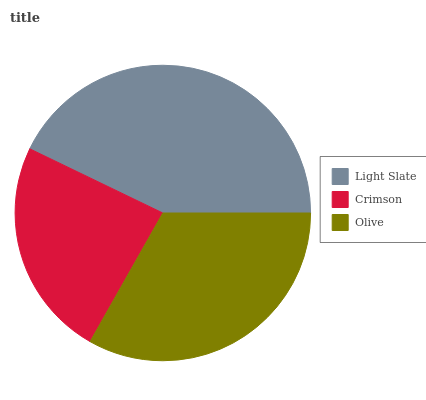Is Crimson the minimum?
Answer yes or no. Yes. Is Light Slate the maximum?
Answer yes or no. Yes. Is Olive the minimum?
Answer yes or no. No. Is Olive the maximum?
Answer yes or no. No. Is Olive greater than Crimson?
Answer yes or no. Yes. Is Crimson less than Olive?
Answer yes or no. Yes. Is Crimson greater than Olive?
Answer yes or no. No. Is Olive less than Crimson?
Answer yes or no. No. Is Olive the high median?
Answer yes or no. Yes. Is Olive the low median?
Answer yes or no. Yes. Is Light Slate the high median?
Answer yes or no. No. Is Light Slate the low median?
Answer yes or no. No. 